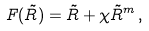<formula> <loc_0><loc_0><loc_500><loc_500>F ( \tilde { R } ) = \tilde { R } + \chi \tilde { R } ^ { m } \, ,</formula> 